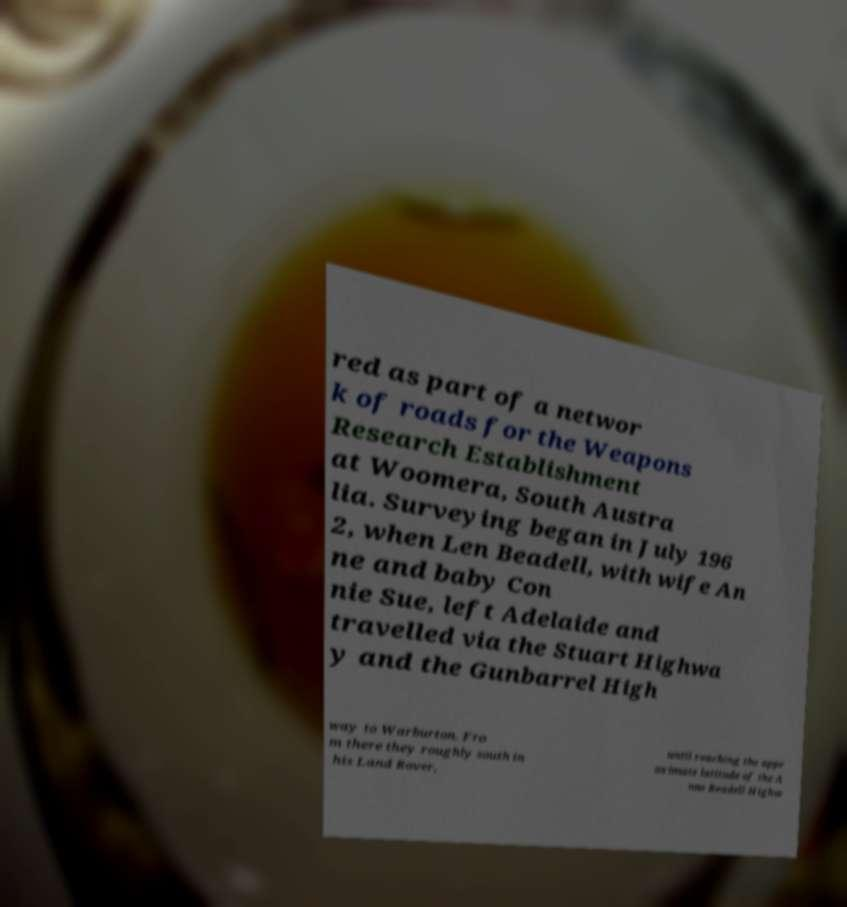Please identify and transcribe the text found in this image. red as part of a networ k of roads for the Weapons Research Establishment at Woomera, South Austra lia. Surveying began in July 196 2, when Len Beadell, with wife An ne and baby Con nie Sue, left Adelaide and travelled via the Stuart Highwa y and the Gunbarrel High way to Warburton. Fro m there they roughly south in his Land Rover, until reaching the appr oximate latitude of the A nne Beadell Highw 